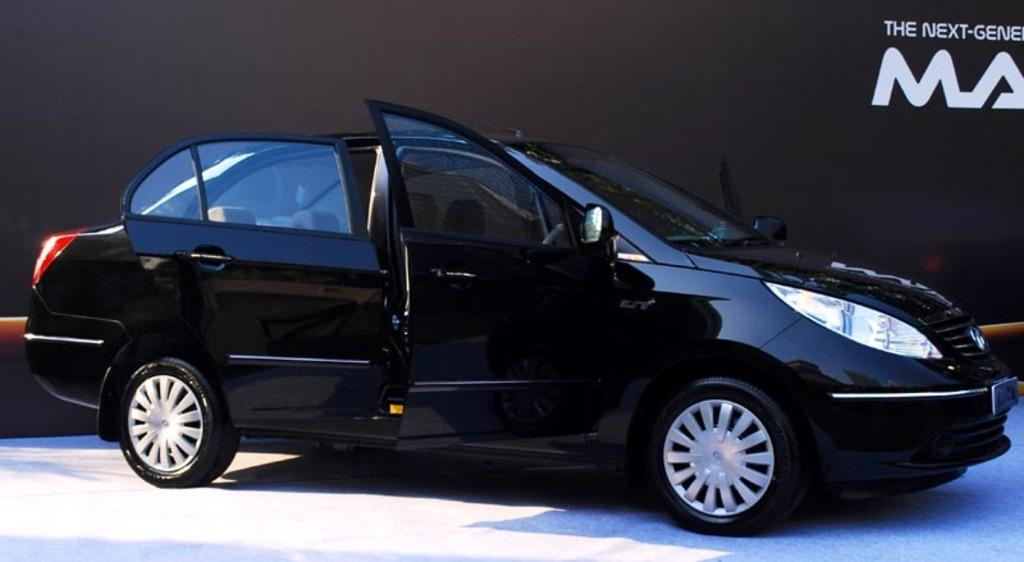What is the main subject of the image? The main subject of the image is a car. Can you describe the car in the image? The car is black in color and is located in the center of the image. What else can be seen on the right side of the image? There is text on the right side of the image. What committee is responsible for the design of the car in the image? There is no information about a committee responsible for the design of the car in the image. What company manufactures the car in the image? There is no information about the company that manufactures the car in the image. 